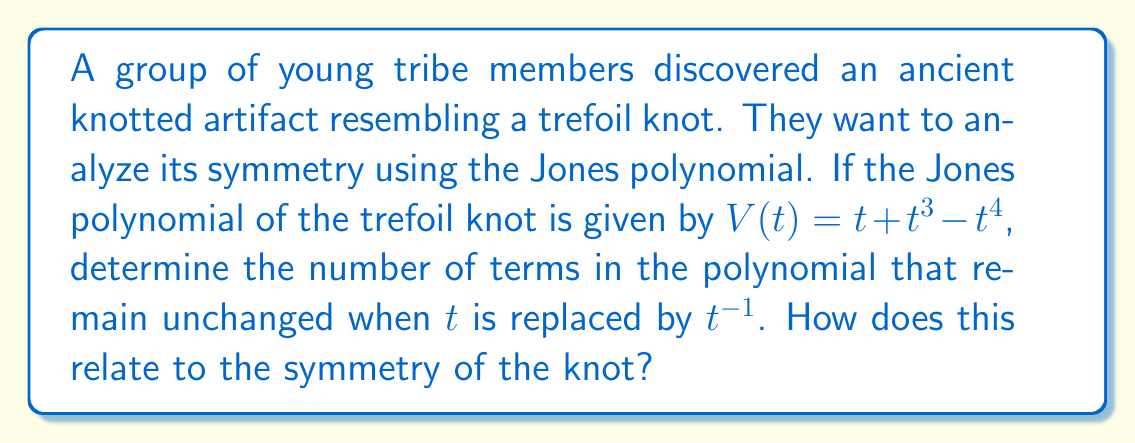Can you solve this math problem? To analyze the symmetry of the trefoil knot using the Jones polynomial, we need to follow these steps:

1) The given Jones polynomial is $V(t) = t + t^3 - t^4$.

2) To check for symmetry, we replace $t$ with $t^{-1}$ in the polynomial:
   $V(t^{-1}) = t^{-1} + t^{-3} - t^{-4}$

3) Multiply both sides by $t^4$ to clear negative exponents:
   $t^4 V(t^{-1}) = t^3 + t + t^0$

4) Compare this with the original polynomial $V(t) = t + t^3 - t^4$:
   - The $t$ and $t^3$ terms remain unchanged
   - The $t^4$ term changes to $t^0$ (constant term)

5) Count the number of terms that remain unchanged: 2 (the $t$ and $t^3$ terms)

6) This symmetry in the Jones polynomial reflects the amphicheirality of the trefoil knot. An amphicheiral knot is equivalent to its mirror image.

7) The number of unchanged terms (2) indicates that the trefoil knot has a rotational symmetry of order 3 (120° rotation).

This analysis shows that the Jones polynomial can reveal important symmetry properties of knots, which is particularly relevant for understanding traditional knotted artifacts.
Answer: 2 unchanged terms; indicates 3-fold rotational symmetry 